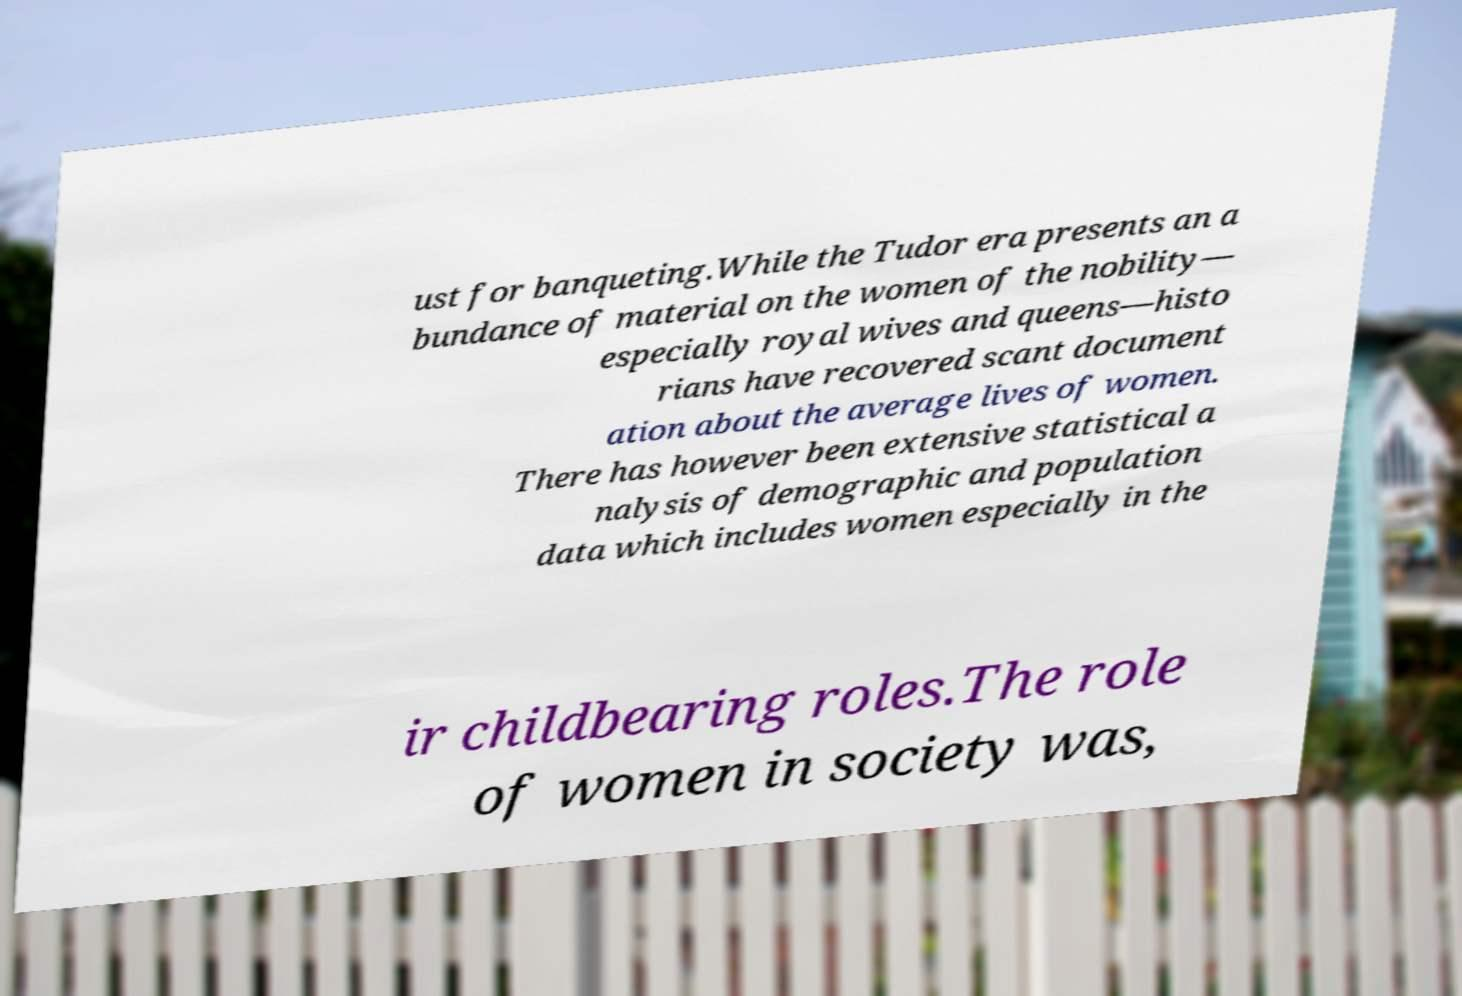Please read and relay the text visible in this image. What does it say? ust for banqueting.While the Tudor era presents an a bundance of material on the women of the nobility— especially royal wives and queens—histo rians have recovered scant document ation about the average lives of women. There has however been extensive statistical a nalysis of demographic and population data which includes women especially in the ir childbearing roles.The role of women in society was, 